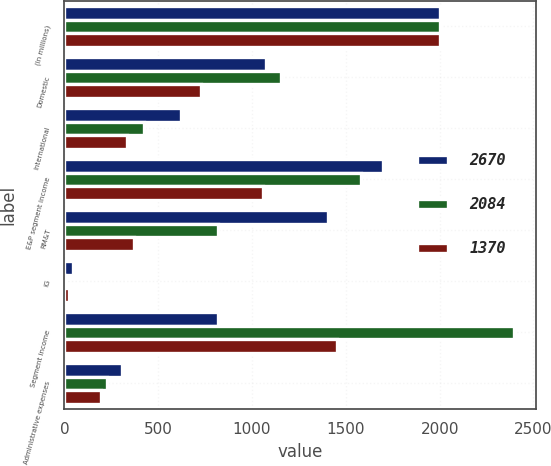Convert chart to OTSL. <chart><loc_0><loc_0><loc_500><loc_500><stacked_bar_chart><ecel><fcel>(In millions)<fcel>Domestic<fcel>International<fcel>E&P segment income<fcel>RM&T<fcel>IG<fcel>Segment income<fcel>Administrative expenses<nl><fcel>2670<fcel>2004<fcel>1073<fcel>623<fcel>1696<fcel>1406<fcel>48<fcel>819<fcel>307<nl><fcel>2084<fcel>2003<fcel>1155<fcel>425<fcel>1580<fcel>819<fcel>3<fcel>2396<fcel>227<nl><fcel>1370<fcel>2002<fcel>726<fcel>333<fcel>1059<fcel>372<fcel>23<fcel>1454<fcel>194<nl></chart> 